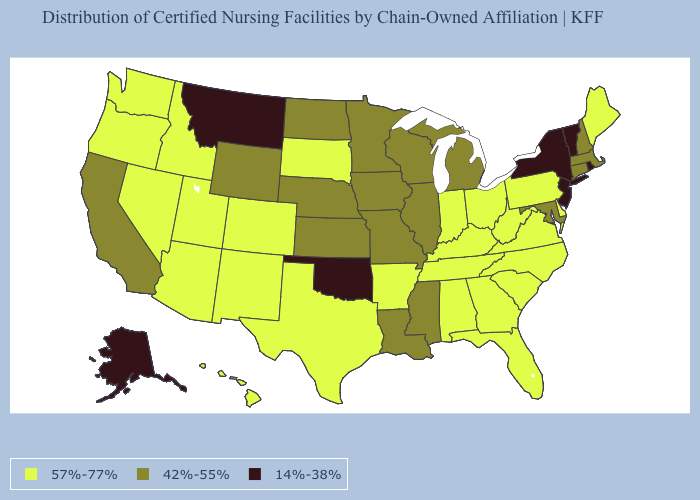Name the states that have a value in the range 42%-55%?
Short answer required. California, Connecticut, Illinois, Iowa, Kansas, Louisiana, Maryland, Massachusetts, Michigan, Minnesota, Mississippi, Missouri, Nebraska, New Hampshire, North Dakota, Wisconsin, Wyoming. Among the states that border West Virginia , does Ohio have the lowest value?
Answer briefly. No. How many symbols are there in the legend?
Concise answer only. 3. Which states hav the highest value in the South?
Give a very brief answer. Alabama, Arkansas, Delaware, Florida, Georgia, Kentucky, North Carolina, South Carolina, Tennessee, Texas, Virginia, West Virginia. What is the lowest value in the USA?
Concise answer only. 14%-38%. Among the states that border New Mexico , which have the highest value?
Short answer required. Arizona, Colorado, Texas, Utah. What is the value of Massachusetts?
Answer briefly. 42%-55%. Which states have the highest value in the USA?
Be succinct. Alabama, Arizona, Arkansas, Colorado, Delaware, Florida, Georgia, Hawaii, Idaho, Indiana, Kentucky, Maine, Nevada, New Mexico, North Carolina, Ohio, Oregon, Pennsylvania, South Carolina, South Dakota, Tennessee, Texas, Utah, Virginia, Washington, West Virginia. Which states have the highest value in the USA?
Concise answer only. Alabama, Arizona, Arkansas, Colorado, Delaware, Florida, Georgia, Hawaii, Idaho, Indiana, Kentucky, Maine, Nevada, New Mexico, North Carolina, Ohio, Oregon, Pennsylvania, South Carolina, South Dakota, Tennessee, Texas, Utah, Virginia, Washington, West Virginia. Does the first symbol in the legend represent the smallest category?
Give a very brief answer. No. What is the lowest value in states that border Ohio?
Quick response, please. 42%-55%. What is the lowest value in the West?
Keep it brief. 14%-38%. What is the highest value in the USA?
Quick response, please. 57%-77%. Among the states that border Maryland , which have the highest value?
Be succinct. Delaware, Pennsylvania, Virginia, West Virginia. Name the states that have a value in the range 57%-77%?
Quick response, please. Alabama, Arizona, Arkansas, Colorado, Delaware, Florida, Georgia, Hawaii, Idaho, Indiana, Kentucky, Maine, Nevada, New Mexico, North Carolina, Ohio, Oregon, Pennsylvania, South Carolina, South Dakota, Tennessee, Texas, Utah, Virginia, Washington, West Virginia. 